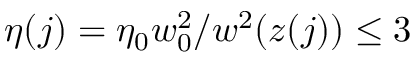Convert formula to latex. <formula><loc_0><loc_0><loc_500><loc_500>\eta ( j ) = \eta _ { 0 } w _ { 0 } ^ { 2 } / w ^ { 2 } ( z ( j ) ) \leq 3</formula> 